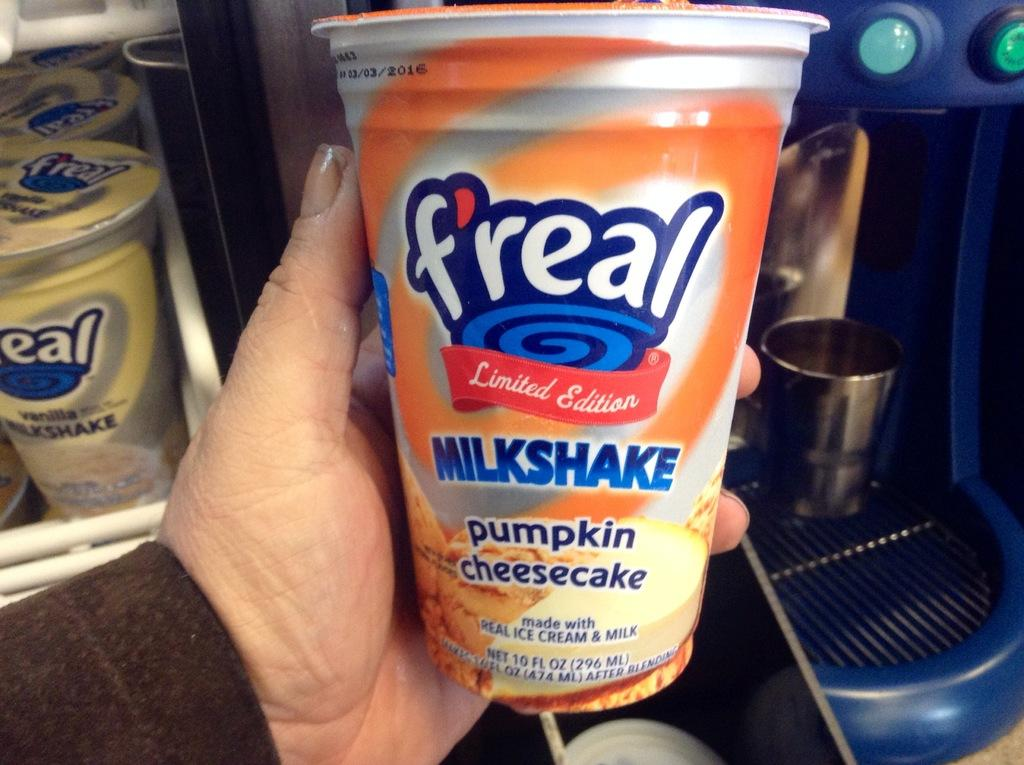What objects are present in the image that are used for drinking? There are glasses in the image. Can you describe the action involving one of the glasses? A person's hand is holding a glass. What can be seen on the right side of the image? There is a blue machine on the right side of the image. How many girls are sitting on the beds in the image? There are no girls or beds present in the image. 